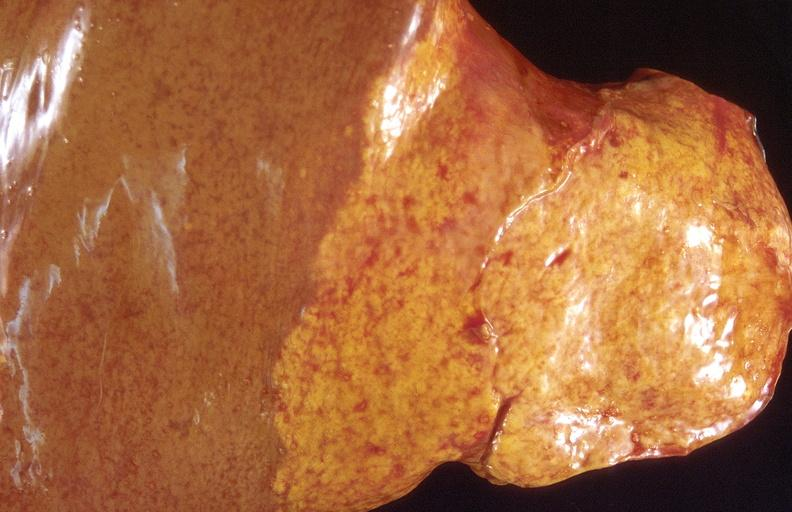s digital infarcts bacterial endocarditis present?
Answer the question using a single word or phrase. No 